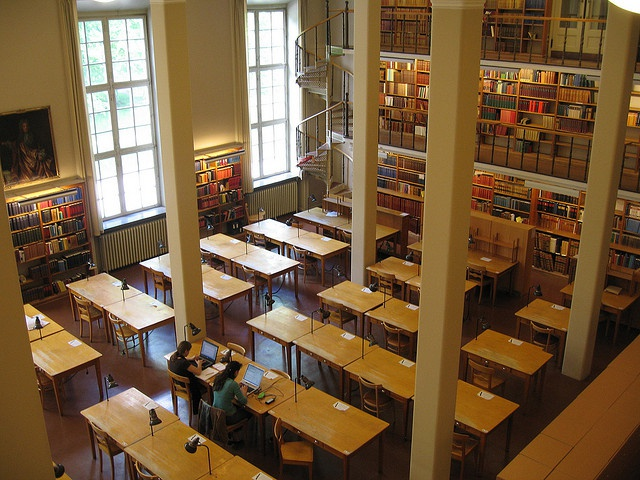Describe the objects in this image and their specific colors. I can see book in olive, maroon, and black tones, chair in olive, black, and maroon tones, dining table in olive, lightgray, tan, and maroon tones, dining table in olive, lightgray, tan, black, and maroon tones, and dining table in olive, tan, maroon, and black tones in this image. 